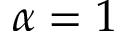<formula> <loc_0><loc_0><loc_500><loc_500>\alpha = 1</formula> 